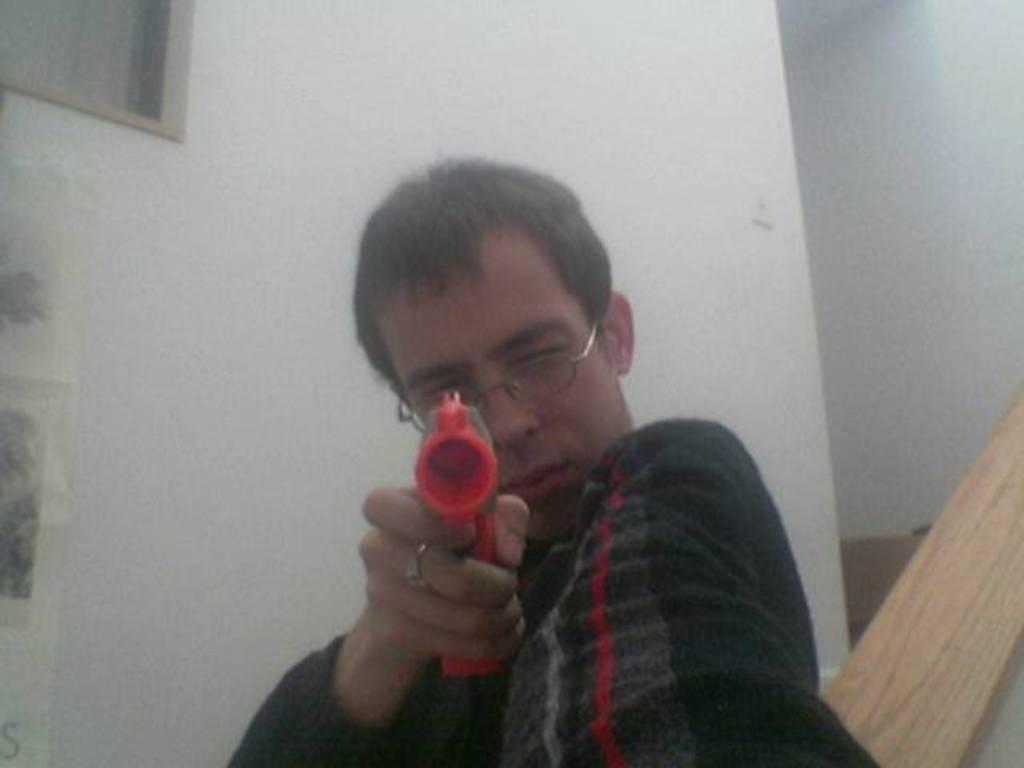Please provide a concise description of this image. A man is holding an object, this is wall. 